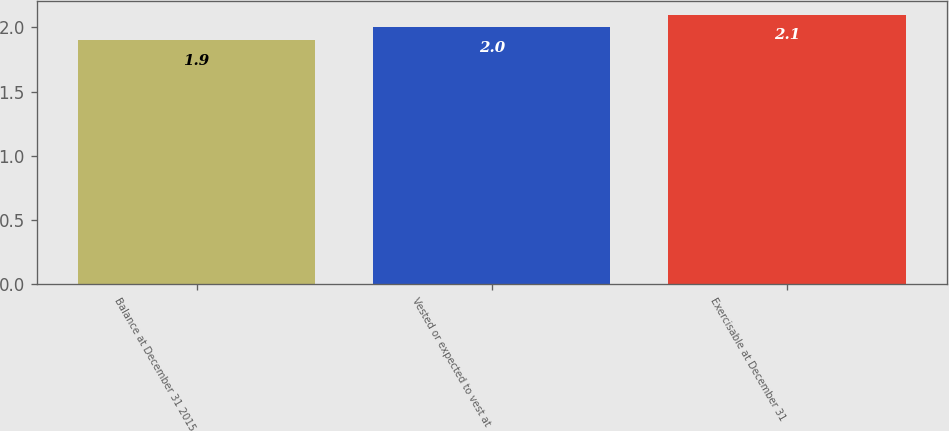Convert chart. <chart><loc_0><loc_0><loc_500><loc_500><bar_chart><fcel>Balance at December 31 2015<fcel>Vested or expected to vest at<fcel>Exercisable at December 31<nl><fcel>1.9<fcel>2<fcel>2.1<nl></chart> 